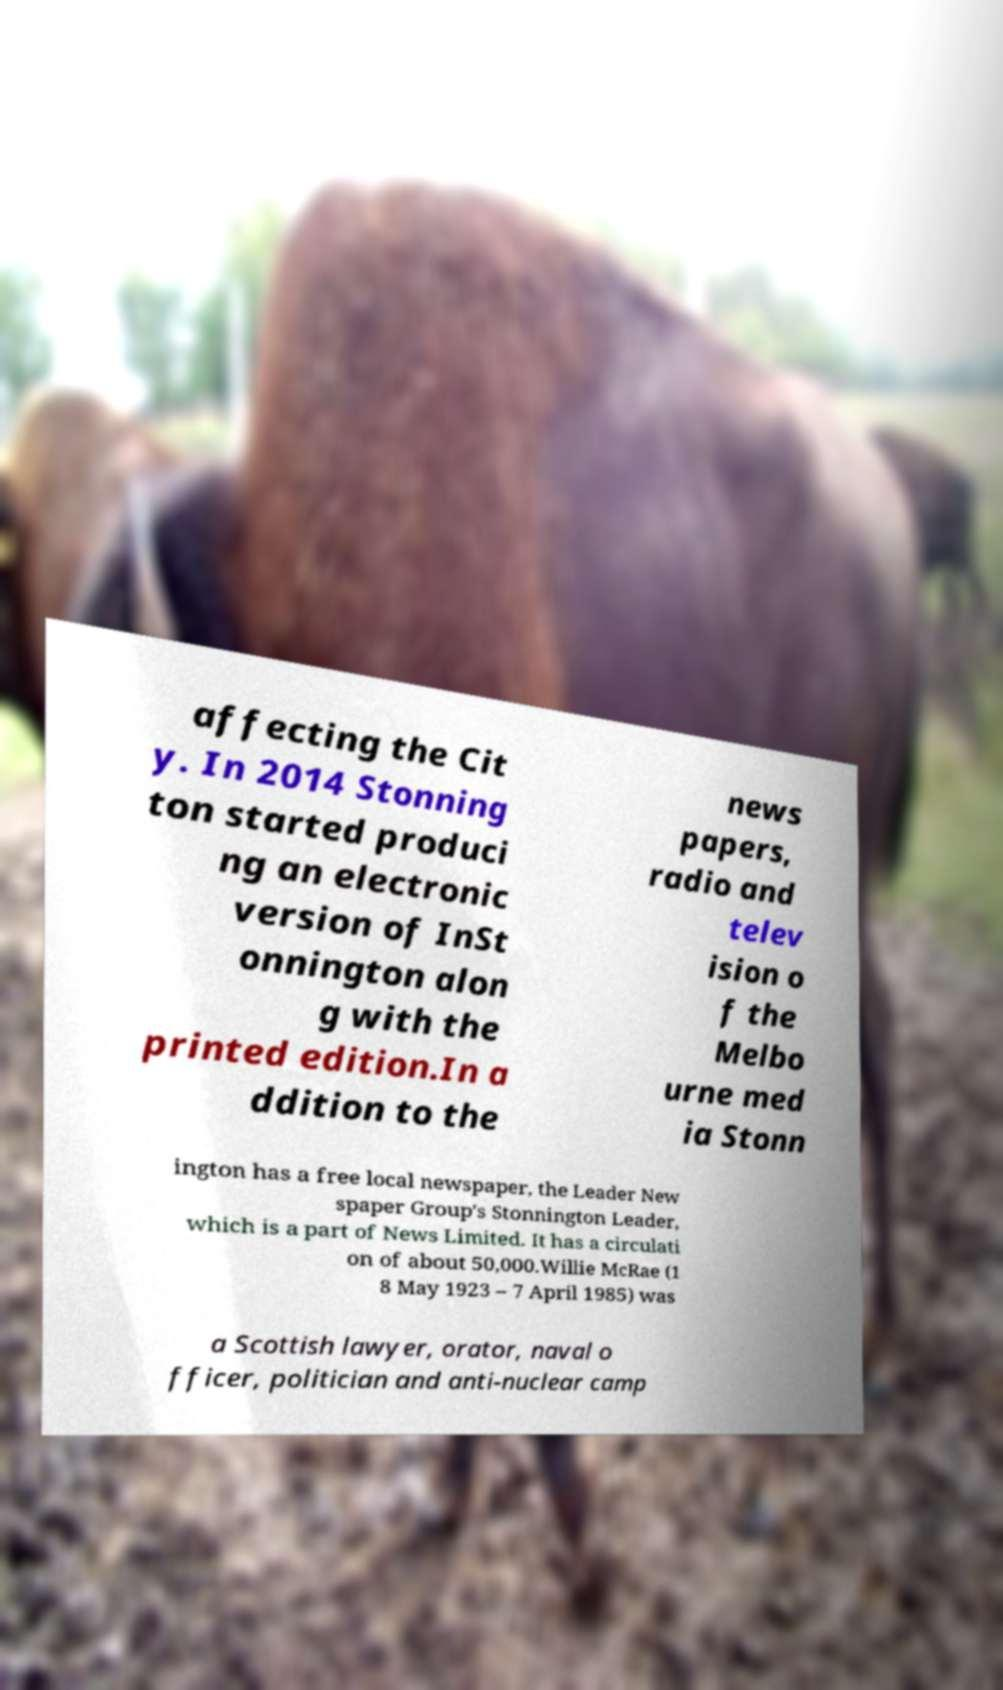Could you extract and type out the text from this image? affecting the Cit y. In 2014 Stonning ton started produci ng an electronic version of InSt onnington alon g with the printed edition.In a ddition to the news papers, radio and telev ision o f the Melbo urne med ia Stonn ington has a free local newspaper, the Leader New spaper Group's Stonnington Leader, which is a part of News Limited. It has a circulati on of about 50,000.Willie McRae (1 8 May 1923 – 7 April 1985) was a Scottish lawyer, orator, naval o fficer, politician and anti-nuclear camp 